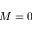Convert formula to latex. <formula><loc_0><loc_0><loc_500><loc_500>M = 0</formula> 